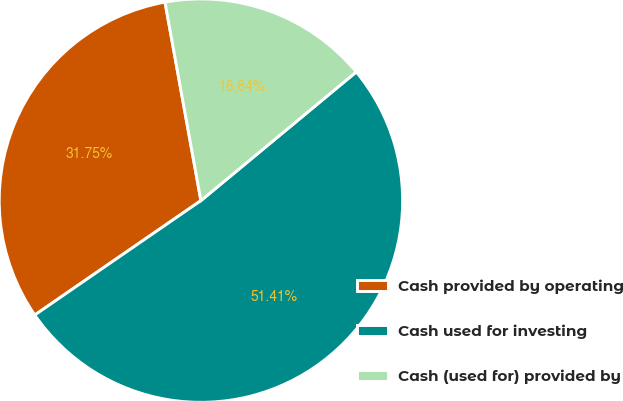Convert chart to OTSL. <chart><loc_0><loc_0><loc_500><loc_500><pie_chart><fcel>Cash provided by operating<fcel>Cash used for investing<fcel>Cash (used for) provided by<nl><fcel>31.75%<fcel>51.42%<fcel>16.84%<nl></chart> 